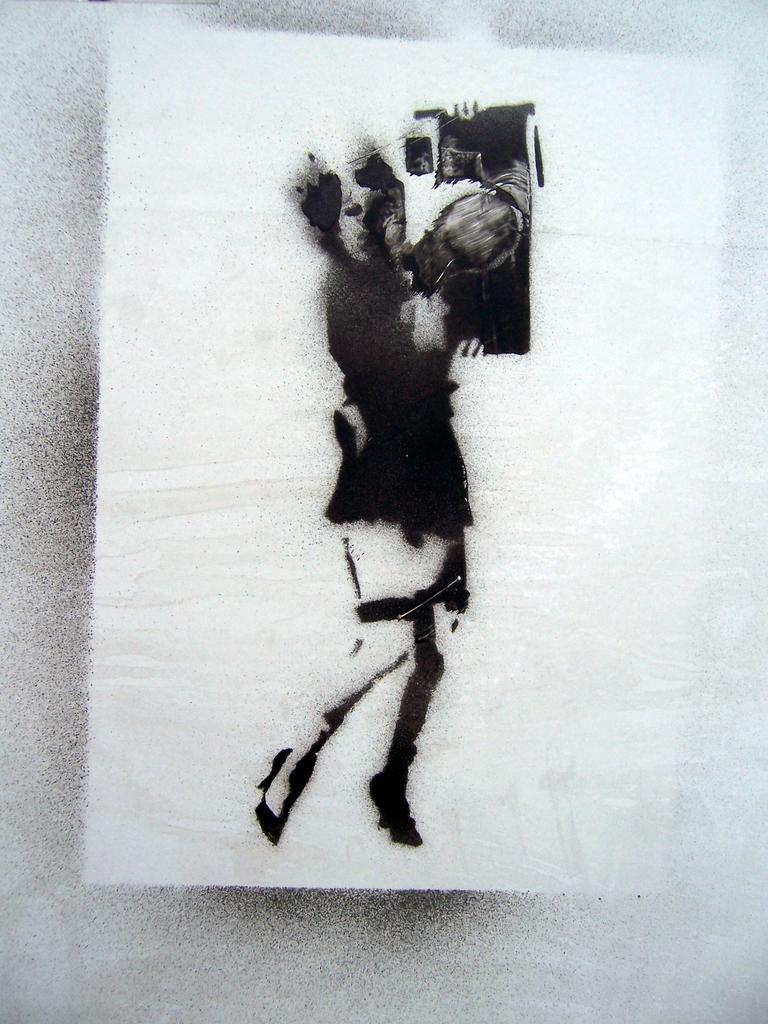What is the main subject of the image? There is a drawing of a person in the center of the image. What is the person in the drawing doing? The person in the drawing is holding objects. What can be seen behind the drawing? There is a background in the image, which consists of paper. What grade did the person in the drawing receive for their drawing skills? There is no indication of a grade or evaluation in the image, as it is a drawing of a person holding objects with a paper background. 